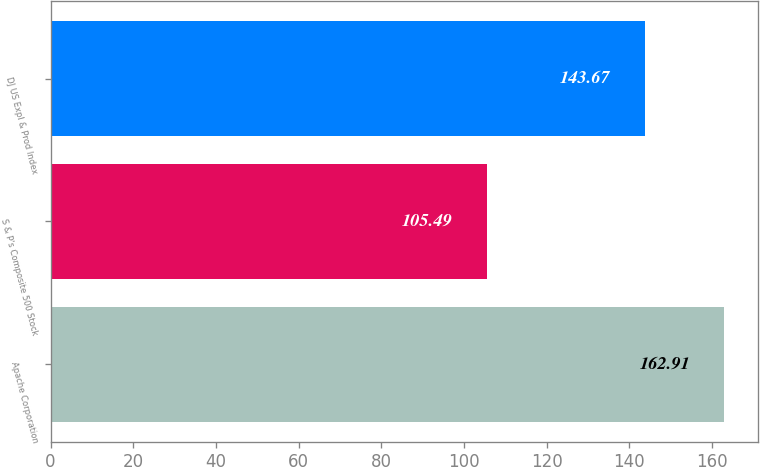Convert chart. <chart><loc_0><loc_0><loc_500><loc_500><bar_chart><fcel>Apache Corporation<fcel>S & P's Composite 500 Stock<fcel>DJ US Expl & Prod Index<nl><fcel>162.91<fcel>105.49<fcel>143.67<nl></chart> 